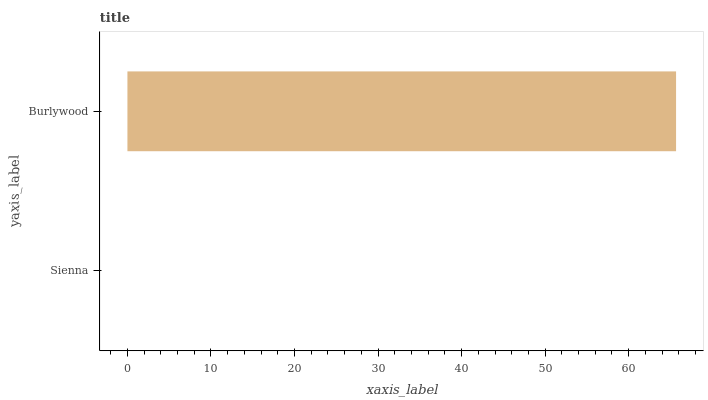Is Sienna the minimum?
Answer yes or no. Yes. Is Burlywood the maximum?
Answer yes or no. Yes. Is Burlywood the minimum?
Answer yes or no. No. Is Burlywood greater than Sienna?
Answer yes or no. Yes. Is Sienna less than Burlywood?
Answer yes or no. Yes. Is Sienna greater than Burlywood?
Answer yes or no. No. Is Burlywood less than Sienna?
Answer yes or no. No. Is Burlywood the high median?
Answer yes or no. Yes. Is Sienna the low median?
Answer yes or no. Yes. Is Sienna the high median?
Answer yes or no. No. Is Burlywood the low median?
Answer yes or no. No. 